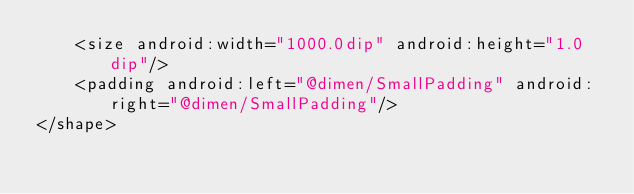Convert code to text. <code><loc_0><loc_0><loc_500><loc_500><_XML_>    <size android:width="1000.0dip" android:height="1.0dip"/>
    <padding android:left="@dimen/SmallPadding" android:right="@dimen/SmallPadding"/>
</shape></code> 